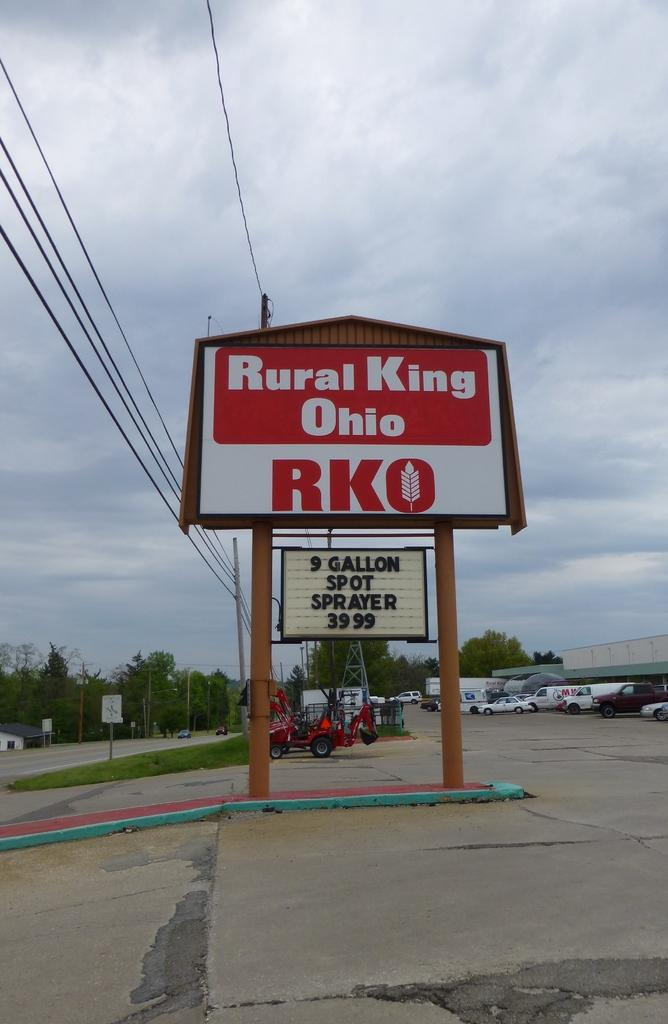<image>
Write a terse but informative summary of the picture. A large sign for the Rural King Ohio 